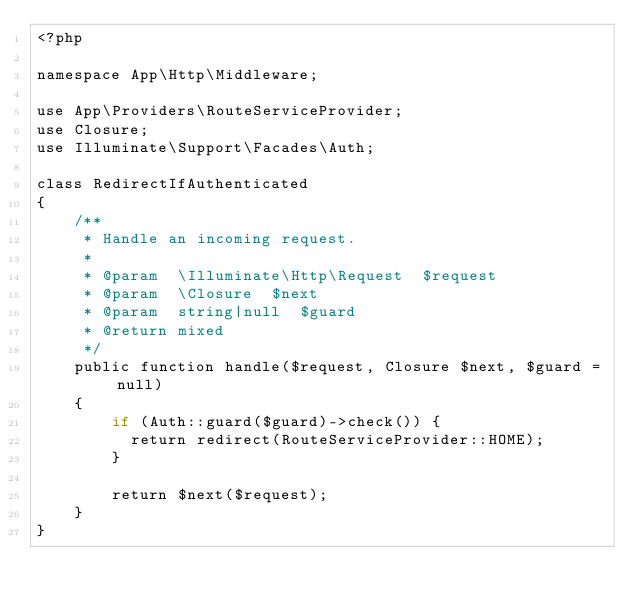Convert code to text. <code><loc_0><loc_0><loc_500><loc_500><_PHP_><?php

namespace App\Http\Middleware;

use App\Providers\RouteServiceProvider;
use Closure;
use Illuminate\Support\Facades\Auth;

class RedirectIfAuthenticated
{
    /**
     * Handle an incoming request.
     *
     * @param  \Illuminate\Http\Request  $request
     * @param  \Closure  $next
     * @param  string|null  $guard
     * @return mixed
     */
    public function handle($request, Closure $next, $guard = null)
    {
        if (Auth::guard($guard)->check()) {
          return redirect(RouteServiceProvider::HOME);
        }

        return $next($request);
    }
}
</code> 